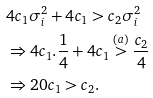<formula> <loc_0><loc_0><loc_500><loc_500>& 4 c _ { 1 } \sigma _ { i } ^ { 2 } + 4 c _ { 1 } > c _ { 2 } \sigma _ { i } ^ { 2 } \\ & \Rightarrow 4 c _ { 1 } . \frac { 1 } { 4 } + 4 c _ { 1 } \overset { ( a ) } { > } \frac { c _ { 2 } } { 4 } \\ & \Rightarrow 2 0 c _ { 1 } > c _ { 2 } .</formula> 